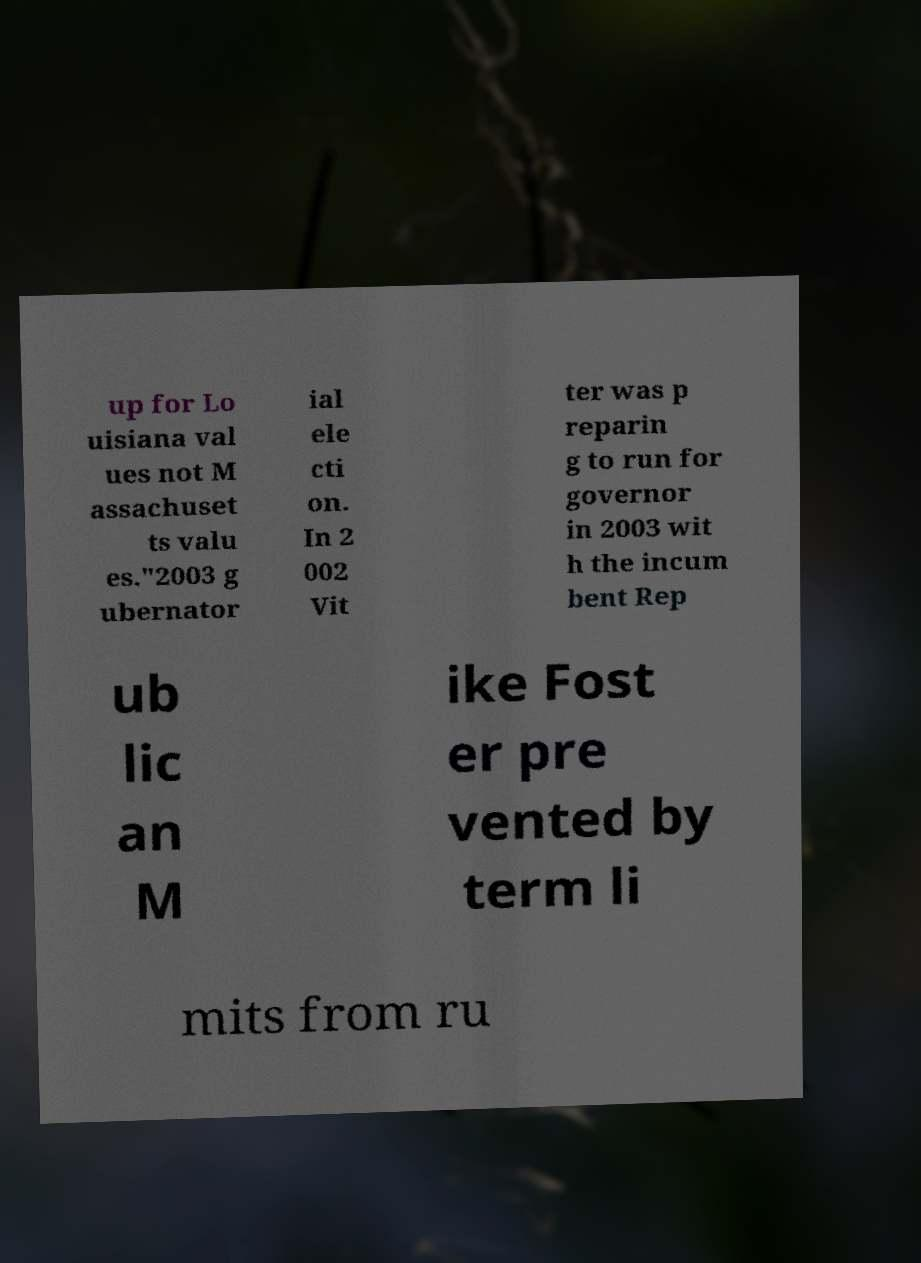Can you read and provide the text displayed in the image?This photo seems to have some interesting text. Can you extract and type it out for me? up for Lo uisiana val ues not M assachuset ts valu es."2003 g ubernator ial ele cti on. In 2 002 Vit ter was p reparin g to run for governor in 2003 wit h the incum bent Rep ub lic an M ike Fost er pre vented by term li mits from ru 